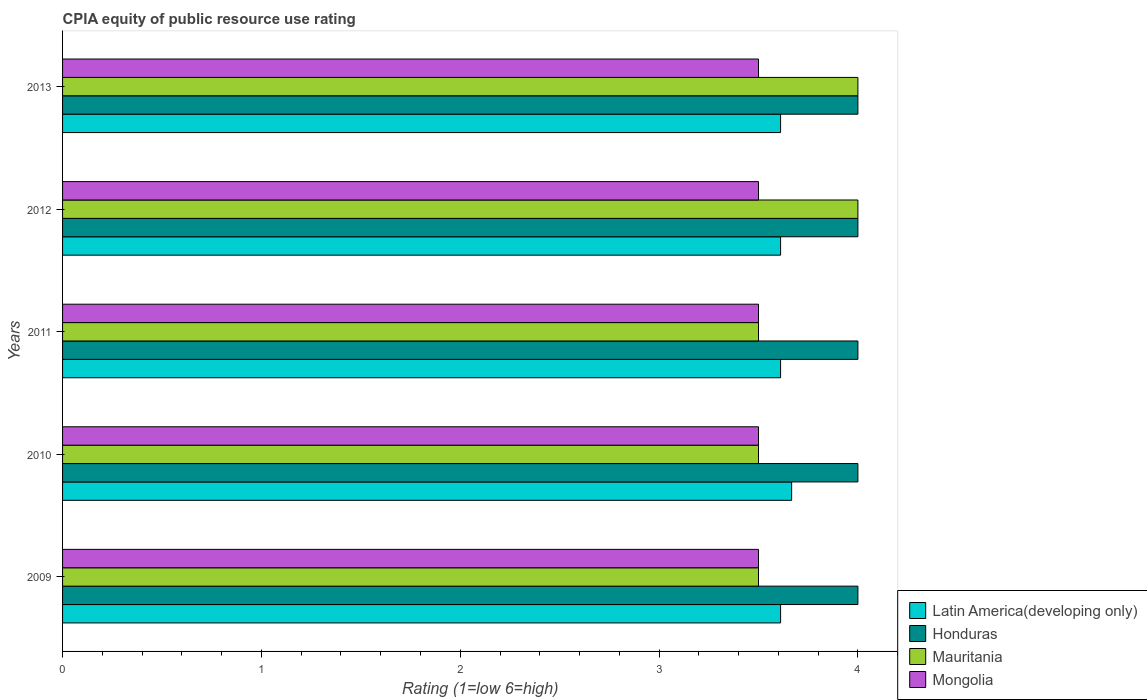How many different coloured bars are there?
Your answer should be compact. 4. How many groups of bars are there?
Your response must be concise. 5. Are the number of bars on each tick of the Y-axis equal?
Offer a very short reply. Yes. How many bars are there on the 3rd tick from the bottom?
Make the answer very short. 4. What is the label of the 3rd group of bars from the top?
Offer a very short reply. 2011. In how many cases, is the number of bars for a given year not equal to the number of legend labels?
Give a very brief answer. 0. What is the CPIA rating in Latin America(developing only) in 2009?
Make the answer very short. 3.61. Across all years, what is the minimum CPIA rating in Mongolia?
Provide a short and direct response. 3.5. In which year was the CPIA rating in Mauritania minimum?
Keep it short and to the point. 2009. What is the total CPIA rating in Latin America(developing only) in the graph?
Your answer should be very brief. 18.11. What is the difference between the CPIA rating in Honduras in 2010 and the CPIA rating in Latin America(developing only) in 2011?
Your answer should be compact. 0.39. In the year 2013, what is the difference between the CPIA rating in Mongolia and CPIA rating in Mauritania?
Give a very brief answer. -0.5. In how many years, is the CPIA rating in Honduras greater than 1.2 ?
Make the answer very short. 5. What is the ratio of the CPIA rating in Mauritania in 2009 to that in 2011?
Your response must be concise. 1. Is the CPIA rating in Mauritania in 2010 less than that in 2012?
Keep it short and to the point. Yes. What is the difference between the highest and the second highest CPIA rating in Latin America(developing only)?
Make the answer very short. 0.06. What is the difference between the highest and the lowest CPIA rating in Honduras?
Your answer should be very brief. 0. Is the sum of the CPIA rating in Latin America(developing only) in 2012 and 2013 greater than the maximum CPIA rating in Mauritania across all years?
Ensure brevity in your answer.  Yes. What does the 1st bar from the top in 2012 represents?
Offer a terse response. Mongolia. What does the 4th bar from the bottom in 2011 represents?
Offer a terse response. Mongolia. Is it the case that in every year, the sum of the CPIA rating in Latin America(developing only) and CPIA rating in Mauritania is greater than the CPIA rating in Honduras?
Provide a succinct answer. Yes. How many bars are there?
Make the answer very short. 20. How many years are there in the graph?
Offer a terse response. 5. What is the difference between two consecutive major ticks on the X-axis?
Your response must be concise. 1. Are the values on the major ticks of X-axis written in scientific E-notation?
Your response must be concise. No. Does the graph contain grids?
Give a very brief answer. No. Where does the legend appear in the graph?
Your response must be concise. Bottom right. How many legend labels are there?
Your answer should be very brief. 4. How are the legend labels stacked?
Make the answer very short. Vertical. What is the title of the graph?
Keep it short and to the point. CPIA equity of public resource use rating. Does "Bahrain" appear as one of the legend labels in the graph?
Make the answer very short. No. What is the label or title of the X-axis?
Keep it short and to the point. Rating (1=low 6=high). What is the Rating (1=low 6=high) of Latin America(developing only) in 2009?
Provide a short and direct response. 3.61. What is the Rating (1=low 6=high) of Honduras in 2009?
Ensure brevity in your answer.  4. What is the Rating (1=low 6=high) of Mauritania in 2009?
Your response must be concise. 3.5. What is the Rating (1=low 6=high) in Mongolia in 2009?
Give a very brief answer. 3.5. What is the Rating (1=low 6=high) of Latin America(developing only) in 2010?
Offer a very short reply. 3.67. What is the Rating (1=low 6=high) in Honduras in 2010?
Your answer should be very brief. 4. What is the Rating (1=low 6=high) in Latin America(developing only) in 2011?
Keep it short and to the point. 3.61. What is the Rating (1=low 6=high) in Mauritania in 2011?
Your answer should be compact. 3.5. What is the Rating (1=low 6=high) in Mongolia in 2011?
Your response must be concise. 3.5. What is the Rating (1=low 6=high) in Latin America(developing only) in 2012?
Your response must be concise. 3.61. What is the Rating (1=low 6=high) of Honduras in 2012?
Give a very brief answer. 4. What is the Rating (1=low 6=high) of Latin America(developing only) in 2013?
Offer a very short reply. 3.61. What is the Rating (1=low 6=high) in Honduras in 2013?
Offer a terse response. 4. Across all years, what is the maximum Rating (1=low 6=high) of Latin America(developing only)?
Offer a terse response. 3.67. Across all years, what is the maximum Rating (1=low 6=high) of Mongolia?
Your answer should be compact. 3.5. Across all years, what is the minimum Rating (1=low 6=high) in Latin America(developing only)?
Offer a very short reply. 3.61. What is the total Rating (1=low 6=high) of Latin America(developing only) in the graph?
Provide a succinct answer. 18.11. What is the total Rating (1=low 6=high) of Honduras in the graph?
Offer a terse response. 20. What is the total Rating (1=low 6=high) in Mauritania in the graph?
Ensure brevity in your answer.  18.5. What is the total Rating (1=low 6=high) of Mongolia in the graph?
Your answer should be very brief. 17.5. What is the difference between the Rating (1=low 6=high) of Latin America(developing only) in 2009 and that in 2010?
Make the answer very short. -0.06. What is the difference between the Rating (1=low 6=high) of Latin America(developing only) in 2009 and that in 2011?
Your answer should be compact. 0. What is the difference between the Rating (1=low 6=high) in Latin America(developing only) in 2009 and that in 2012?
Your answer should be very brief. 0. What is the difference between the Rating (1=low 6=high) of Honduras in 2009 and that in 2012?
Offer a terse response. 0. What is the difference between the Rating (1=low 6=high) of Latin America(developing only) in 2010 and that in 2011?
Keep it short and to the point. 0.06. What is the difference between the Rating (1=low 6=high) in Mauritania in 2010 and that in 2011?
Your answer should be compact. 0. What is the difference between the Rating (1=low 6=high) in Mongolia in 2010 and that in 2011?
Make the answer very short. 0. What is the difference between the Rating (1=low 6=high) of Latin America(developing only) in 2010 and that in 2012?
Your response must be concise. 0.06. What is the difference between the Rating (1=low 6=high) of Honduras in 2010 and that in 2012?
Offer a very short reply. 0. What is the difference between the Rating (1=low 6=high) in Mauritania in 2010 and that in 2012?
Offer a very short reply. -0.5. What is the difference between the Rating (1=low 6=high) in Mongolia in 2010 and that in 2012?
Your answer should be compact. 0. What is the difference between the Rating (1=low 6=high) of Latin America(developing only) in 2010 and that in 2013?
Provide a short and direct response. 0.06. What is the difference between the Rating (1=low 6=high) in Mauritania in 2010 and that in 2013?
Your answer should be very brief. -0.5. What is the difference between the Rating (1=low 6=high) in Mongolia in 2010 and that in 2013?
Give a very brief answer. 0. What is the difference between the Rating (1=low 6=high) in Honduras in 2011 and that in 2013?
Offer a very short reply. 0. What is the difference between the Rating (1=low 6=high) of Mauritania in 2011 and that in 2013?
Your answer should be compact. -0.5. What is the difference between the Rating (1=low 6=high) of Mongolia in 2011 and that in 2013?
Offer a terse response. 0. What is the difference between the Rating (1=low 6=high) of Latin America(developing only) in 2012 and that in 2013?
Ensure brevity in your answer.  0. What is the difference between the Rating (1=low 6=high) of Latin America(developing only) in 2009 and the Rating (1=low 6=high) of Honduras in 2010?
Ensure brevity in your answer.  -0.39. What is the difference between the Rating (1=low 6=high) in Latin America(developing only) in 2009 and the Rating (1=low 6=high) in Mauritania in 2010?
Give a very brief answer. 0.11. What is the difference between the Rating (1=low 6=high) in Latin America(developing only) in 2009 and the Rating (1=low 6=high) in Mongolia in 2010?
Give a very brief answer. 0.11. What is the difference between the Rating (1=low 6=high) in Honduras in 2009 and the Rating (1=low 6=high) in Mauritania in 2010?
Ensure brevity in your answer.  0.5. What is the difference between the Rating (1=low 6=high) in Latin America(developing only) in 2009 and the Rating (1=low 6=high) in Honduras in 2011?
Your response must be concise. -0.39. What is the difference between the Rating (1=low 6=high) of Honduras in 2009 and the Rating (1=low 6=high) of Mauritania in 2011?
Provide a short and direct response. 0.5. What is the difference between the Rating (1=low 6=high) of Mauritania in 2009 and the Rating (1=low 6=high) of Mongolia in 2011?
Your response must be concise. 0. What is the difference between the Rating (1=low 6=high) of Latin America(developing only) in 2009 and the Rating (1=low 6=high) of Honduras in 2012?
Ensure brevity in your answer.  -0.39. What is the difference between the Rating (1=low 6=high) in Latin America(developing only) in 2009 and the Rating (1=low 6=high) in Mauritania in 2012?
Provide a succinct answer. -0.39. What is the difference between the Rating (1=low 6=high) of Latin America(developing only) in 2009 and the Rating (1=low 6=high) of Mongolia in 2012?
Offer a terse response. 0.11. What is the difference between the Rating (1=low 6=high) of Latin America(developing only) in 2009 and the Rating (1=low 6=high) of Honduras in 2013?
Your response must be concise. -0.39. What is the difference between the Rating (1=low 6=high) in Latin America(developing only) in 2009 and the Rating (1=low 6=high) in Mauritania in 2013?
Give a very brief answer. -0.39. What is the difference between the Rating (1=low 6=high) in Latin America(developing only) in 2009 and the Rating (1=low 6=high) in Mongolia in 2013?
Your response must be concise. 0.11. What is the difference between the Rating (1=low 6=high) in Honduras in 2009 and the Rating (1=low 6=high) in Mauritania in 2013?
Give a very brief answer. 0. What is the difference between the Rating (1=low 6=high) in Honduras in 2009 and the Rating (1=low 6=high) in Mongolia in 2013?
Provide a succinct answer. 0.5. What is the difference between the Rating (1=low 6=high) in Latin America(developing only) in 2010 and the Rating (1=low 6=high) in Honduras in 2011?
Keep it short and to the point. -0.33. What is the difference between the Rating (1=low 6=high) in Latin America(developing only) in 2010 and the Rating (1=low 6=high) in Mongolia in 2011?
Your response must be concise. 0.17. What is the difference between the Rating (1=low 6=high) of Honduras in 2010 and the Rating (1=low 6=high) of Mauritania in 2011?
Your answer should be compact. 0.5. What is the difference between the Rating (1=low 6=high) of Mauritania in 2010 and the Rating (1=low 6=high) of Mongolia in 2011?
Offer a very short reply. 0. What is the difference between the Rating (1=low 6=high) in Latin America(developing only) in 2010 and the Rating (1=low 6=high) in Honduras in 2012?
Offer a terse response. -0.33. What is the difference between the Rating (1=low 6=high) in Latin America(developing only) in 2010 and the Rating (1=low 6=high) in Mongolia in 2012?
Provide a short and direct response. 0.17. What is the difference between the Rating (1=low 6=high) of Honduras in 2010 and the Rating (1=low 6=high) of Mongolia in 2012?
Ensure brevity in your answer.  0.5. What is the difference between the Rating (1=low 6=high) of Latin America(developing only) in 2010 and the Rating (1=low 6=high) of Mauritania in 2013?
Your response must be concise. -0.33. What is the difference between the Rating (1=low 6=high) in Honduras in 2010 and the Rating (1=low 6=high) in Mongolia in 2013?
Your answer should be compact. 0.5. What is the difference between the Rating (1=low 6=high) in Latin America(developing only) in 2011 and the Rating (1=low 6=high) in Honduras in 2012?
Offer a very short reply. -0.39. What is the difference between the Rating (1=low 6=high) of Latin America(developing only) in 2011 and the Rating (1=low 6=high) of Mauritania in 2012?
Keep it short and to the point. -0.39. What is the difference between the Rating (1=low 6=high) of Latin America(developing only) in 2011 and the Rating (1=low 6=high) of Honduras in 2013?
Give a very brief answer. -0.39. What is the difference between the Rating (1=low 6=high) of Latin America(developing only) in 2011 and the Rating (1=low 6=high) of Mauritania in 2013?
Offer a very short reply. -0.39. What is the difference between the Rating (1=low 6=high) in Latin America(developing only) in 2011 and the Rating (1=low 6=high) in Mongolia in 2013?
Your answer should be very brief. 0.11. What is the difference between the Rating (1=low 6=high) of Latin America(developing only) in 2012 and the Rating (1=low 6=high) of Honduras in 2013?
Offer a very short reply. -0.39. What is the difference between the Rating (1=low 6=high) of Latin America(developing only) in 2012 and the Rating (1=low 6=high) of Mauritania in 2013?
Make the answer very short. -0.39. What is the difference between the Rating (1=low 6=high) of Latin America(developing only) in 2012 and the Rating (1=low 6=high) of Mongolia in 2013?
Provide a succinct answer. 0.11. What is the difference between the Rating (1=low 6=high) in Honduras in 2012 and the Rating (1=low 6=high) in Mongolia in 2013?
Provide a short and direct response. 0.5. What is the average Rating (1=low 6=high) of Latin America(developing only) per year?
Make the answer very short. 3.62. What is the average Rating (1=low 6=high) of Mauritania per year?
Provide a succinct answer. 3.7. In the year 2009, what is the difference between the Rating (1=low 6=high) of Latin America(developing only) and Rating (1=low 6=high) of Honduras?
Ensure brevity in your answer.  -0.39. In the year 2009, what is the difference between the Rating (1=low 6=high) of Latin America(developing only) and Rating (1=low 6=high) of Mauritania?
Keep it short and to the point. 0.11. In the year 2009, what is the difference between the Rating (1=low 6=high) in Latin America(developing only) and Rating (1=low 6=high) in Mongolia?
Provide a short and direct response. 0.11. In the year 2009, what is the difference between the Rating (1=low 6=high) in Honduras and Rating (1=low 6=high) in Mongolia?
Provide a short and direct response. 0.5. In the year 2010, what is the difference between the Rating (1=low 6=high) in Latin America(developing only) and Rating (1=low 6=high) in Honduras?
Your answer should be very brief. -0.33. In the year 2010, what is the difference between the Rating (1=low 6=high) in Latin America(developing only) and Rating (1=low 6=high) in Mauritania?
Make the answer very short. 0.17. In the year 2010, what is the difference between the Rating (1=low 6=high) of Latin America(developing only) and Rating (1=low 6=high) of Mongolia?
Your answer should be very brief. 0.17. In the year 2010, what is the difference between the Rating (1=low 6=high) of Honduras and Rating (1=low 6=high) of Mauritania?
Provide a short and direct response. 0.5. In the year 2010, what is the difference between the Rating (1=low 6=high) of Honduras and Rating (1=low 6=high) of Mongolia?
Offer a very short reply. 0.5. In the year 2010, what is the difference between the Rating (1=low 6=high) of Mauritania and Rating (1=low 6=high) of Mongolia?
Ensure brevity in your answer.  0. In the year 2011, what is the difference between the Rating (1=low 6=high) in Latin America(developing only) and Rating (1=low 6=high) in Honduras?
Your answer should be compact. -0.39. In the year 2011, what is the difference between the Rating (1=low 6=high) of Latin America(developing only) and Rating (1=low 6=high) of Mauritania?
Keep it short and to the point. 0.11. In the year 2011, what is the difference between the Rating (1=low 6=high) of Latin America(developing only) and Rating (1=low 6=high) of Mongolia?
Offer a very short reply. 0.11. In the year 2011, what is the difference between the Rating (1=low 6=high) of Honduras and Rating (1=low 6=high) of Mauritania?
Ensure brevity in your answer.  0.5. In the year 2011, what is the difference between the Rating (1=low 6=high) in Mauritania and Rating (1=low 6=high) in Mongolia?
Provide a succinct answer. 0. In the year 2012, what is the difference between the Rating (1=low 6=high) in Latin America(developing only) and Rating (1=low 6=high) in Honduras?
Offer a very short reply. -0.39. In the year 2012, what is the difference between the Rating (1=low 6=high) in Latin America(developing only) and Rating (1=low 6=high) in Mauritania?
Your response must be concise. -0.39. In the year 2012, what is the difference between the Rating (1=low 6=high) of Honduras and Rating (1=low 6=high) of Mongolia?
Your answer should be very brief. 0.5. In the year 2013, what is the difference between the Rating (1=low 6=high) in Latin America(developing only) and Rating (1=low 6=high) in Honduras?
Provide a succinct answer. -0.39. In the year 2013, what is the difference between the Rating (1=low 6=high) in Latin America(developing only) and Rating (1=low 6=high) in Mauritania?
Your answer should be very brief. -0.39. What is the ratio of the Rating (1=low 6=high) in Latin America(developing only) in 2009 to that in 2010?
Offer a terse response. 0.98. What is the ratio of the Rating (1=low 6=high) of Honduras in 2009 to that in 2011?
Offer a terse response. 1. What is the ratio of the Rating (1=low 6=high) in Mauritania in 2009 to that in 2011?
Ensure brevity in your answer.  1. What is the ratio of the Rating (1=low 6=high) of Mongolia in 2009 to that in 2011?
Offer a terse response. 1. What is the ratio of the Rating (1=low 6=high) of Latin America(developing only) in 2009 to that in 2012?
Provide a short and direct response. 1. What is the ratio of the Rating (1=low 6=high) in Honduras in 2009 to that in 2012?
Ensure brevity in your answer.  1. What is the ratio of the Rating (1=low 6=high) in Mongolia in 2009 to that in 2012?
Provide a succinct answer. 1. What is the ratio of the Rating (1=low 6=high) of Latin America(developing only) in 2009 to that in 2013?
Give a very brief answer. 1. What is the ratio of the Rating (1=low 6=high) in Latin America(developing only) in 2010 to that in 2011?
Ensure brevity in your answer.  1.02. What is the ratio of the Rating (1=low 6=high) of Honduras in 2010 to that in 2011?
Keep it short and to the point. 1. What is the ratio of the Rating (1=low 6=high) in Mongolia in 2010 to that in 2011?
Give a very brief answer. 1. What is the ratio of the Rating (1=low 6=high) in Latin America(developing only) in 2010 to that in 2012?
Your answer should be very brief. 1.02. What is the ratio of the Rating (1=low 6=high) in Mongolia in 2010 to that in 2012?
Make the answer very short. 1. What is the ratio of the Rating (1=low 6=high) of Latin America(developing only) in 2010 to that in 2013?
Keep it short and to the point. 1.02. What is the ratio of the Rating (1=low 6=high) of Honduras in 2010 to that in 2013?
Give a very brief answer. 1. What is the ratio of the Rating (1=low 6=high) of Mauritania in 2010 to that in 2013?
Your answer should be compact. 0.88. What is the ratio of the Rating (1=low 6=high) of Mongolia in 2010 to that in 2013?
Provide a short and direct response. 1. What is the ratio of the Rating (1=low 6=high) in Mauritania in 2011 to that in 2012?
Keep it short and to the point. 0.88. What is the ratio of the Rating (1=low 6=high) in Honduras in 2011 to that in 2013?
Provide a short and direct response. 1. What is the ratio of the Rating (1=low 6=high) of Mongolia in 2011 to that in 2013?
Provide a succinct answer. 1. What is the ratio of the Rating (1=low 6=high) of Honduras in 2012 to that in 2013?
Your answer should be compact. 1. What is the difference between the highest and the second highest Rating (1=low 6=high) of Latin America(developing only)?
Keep it short and to the point. 0.06. What is the difference between the highest and the second highest Rating (1=low 6=high) of Honduras?
Provide a short and direct response. 0. What is the difference between the highest and the second highest Rating (1=low 6=high) in Mauritania?
Offer a terse response. 0. What is the difference between the highest and the lowest Rating (1=low 6=high) of Latin America(developing only)?
Your answer should be compact. 0.06. What is the difference between the highest and the lowest Rating (1=low 6=high) of Mauritania?
Offer a very short reply. 0.5. 